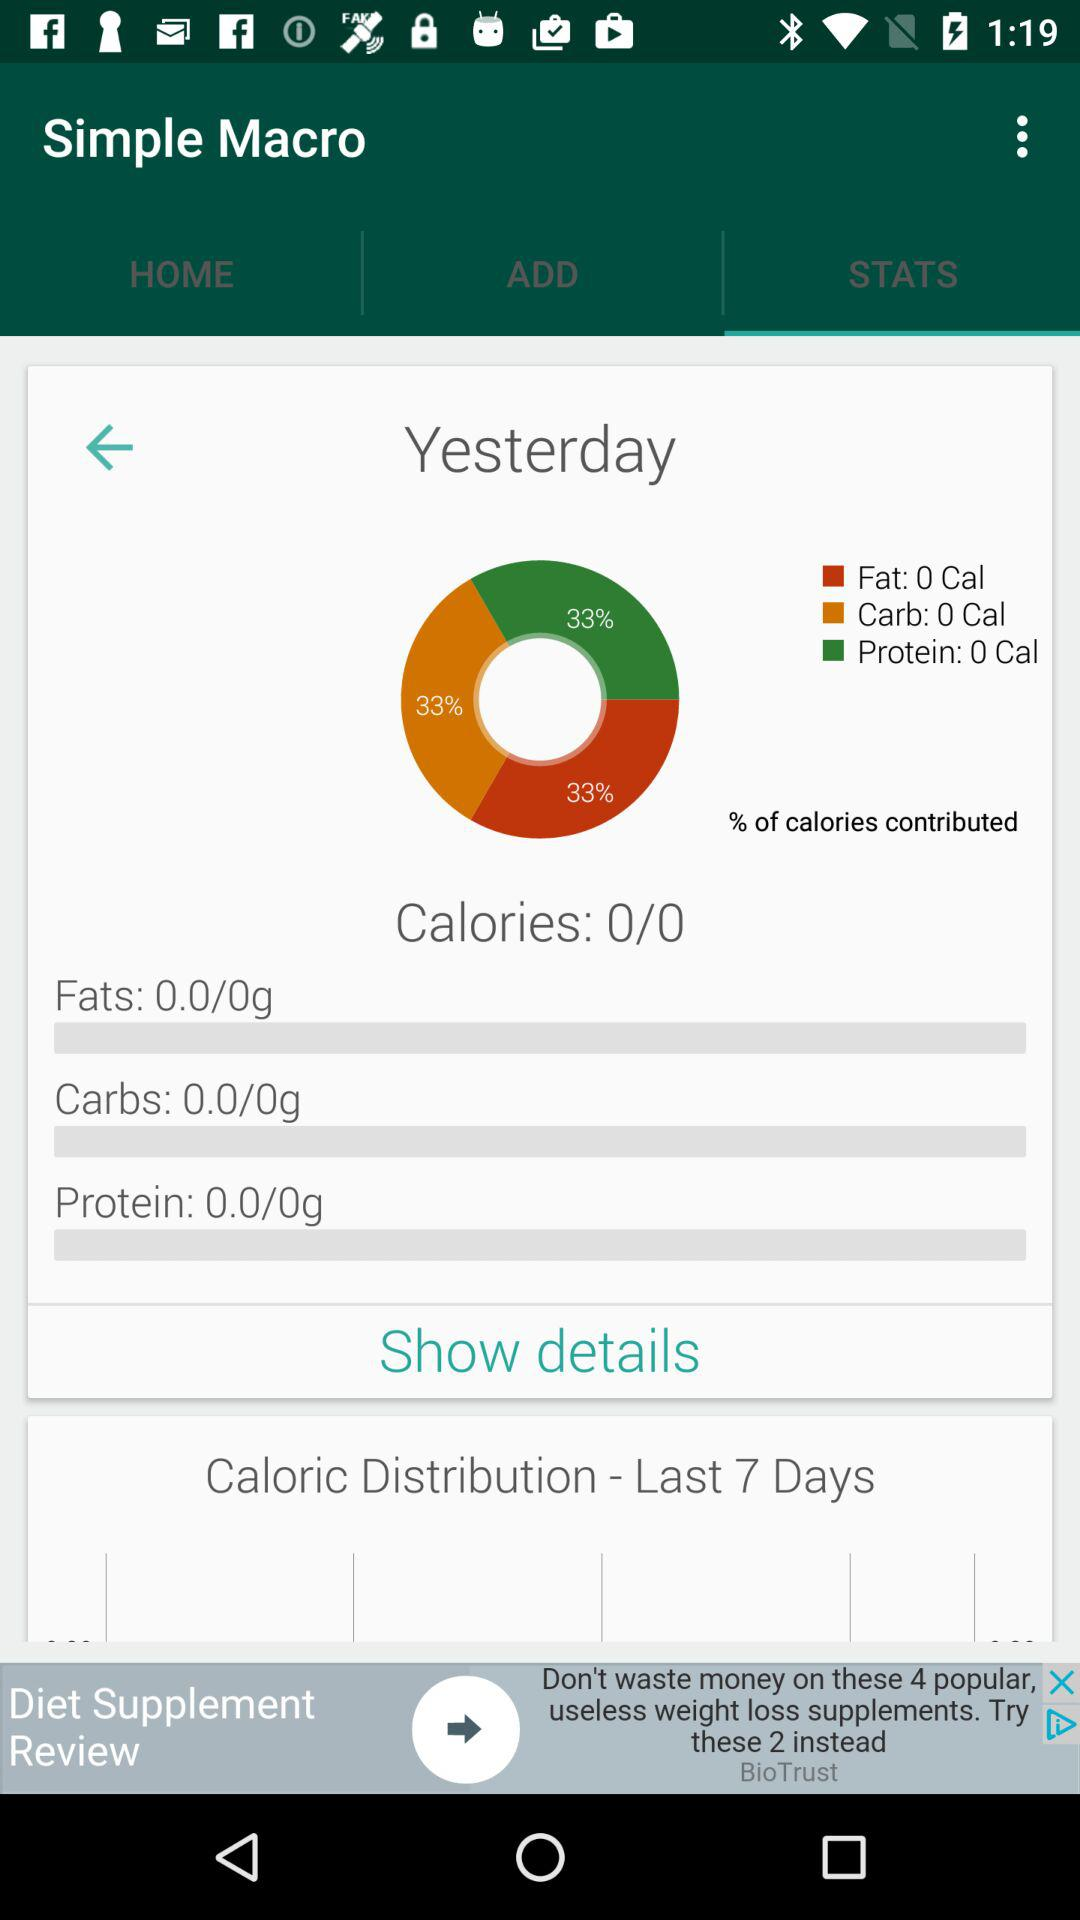What is the total number of calories consumed?
Answer the question using a single word or phrase. 0 